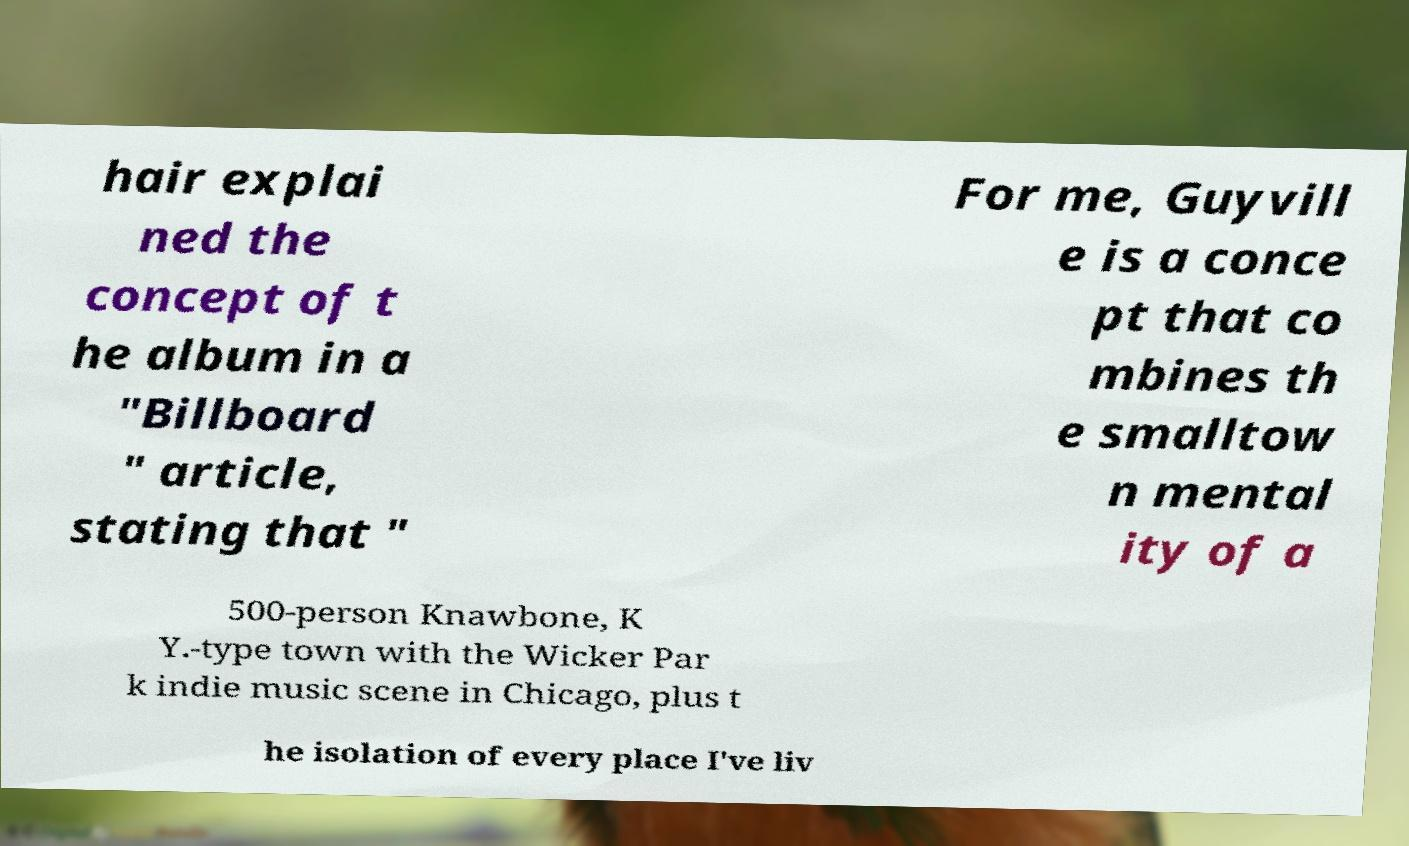Please read and relay the text visible in this image. What does it say? hair explai ned the concept of t he album in a "Billboard " article, stating that " For me, Guyvill e is a conce pt that co mbines th e smalltow n mental ity of a 500-person Knawbone, K Y.-type town with the Wicker Par k indie music scene in Chicago, plus t he isolation of every place I've liv 